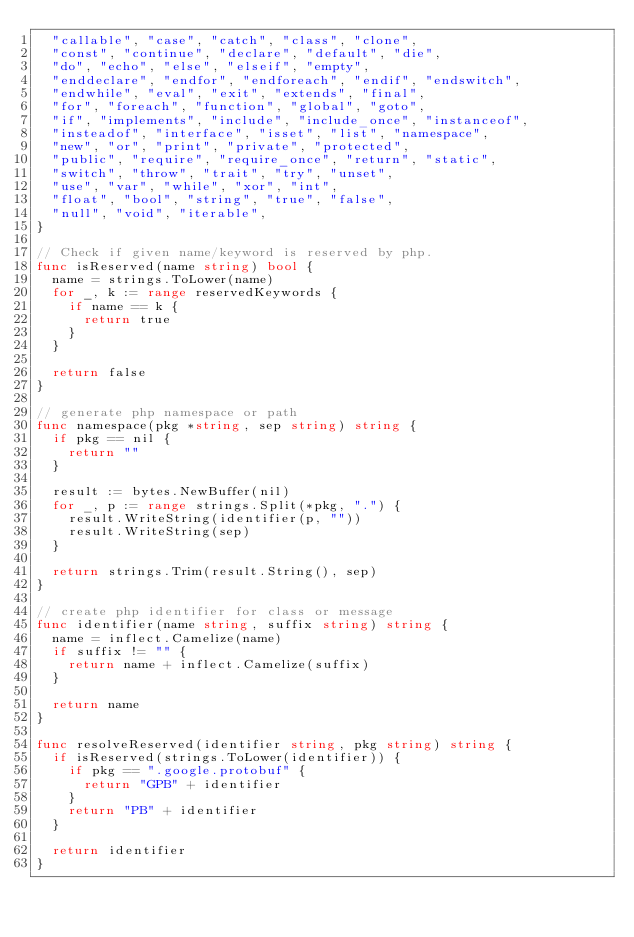<code> <loc_0><loc_0><loc_500><loc_500><_Go_>	"callable", "case", "catch", "class", "clone",
	"const", "continue", "declare", "default", "die",
	"do", "echo", "else", "elseif", "empty",
	"enddeclare", "endfor", "endforeach", "endif", "endswitch",
	"endwhile", "eval", "exit", "extends", "final",
	"for", "foreach", "function", "global", "goto",
	"if", "implements", "include", "include_once", "instanceof",
	"insteadof", "interface", "isset", "list", "namespace",
	"new", "or", "print", "private", "protected",
	"public", "require", "require_once", "return", "static",
	"switch", "throw", "trait", "try", "unset",
	"use", "var", "while", "xor", "int",
	"float", "bool", "string", "true", "false",
	"null", "void", "iterable",
}

// Check if given name/keyword is reserved by php.
func isReserved(name string) bool {
	name = strings.ToLower(name)
	for _, k := range reservedKeywords {
		if name == k {
			return true
		}
	}

	return false
}

// generate php namespace or path
func namespace(pkg *string, sep string) string {
	if pkg == nil {
		return ""
	}

	result := bytes.NewBuffer(nil)
	for _, p := range strings.Split(*pkg, ".") {
		result.WriteString(identifier(p, ""))
		result.WriteString(sep)
	}

	return strings.Trim(result.String(), sep)
}

// create php identifier for class or message
func identifier(name string, suffix string) string {
	name = inflect.Camelize(name)
	if suffix != "" {
		return name + inflect.Camelize(suffix)
	}

	return name
}

func resolveReserved(identifier string, pkg string) string {
	if isReserved(strings.ToLower(identifier)) {
		if pkg == ".google.protobuf" {
			return "GPB" + identifier
		}
		return "PB" + identifier
	}

	return identifier
}
</code> 